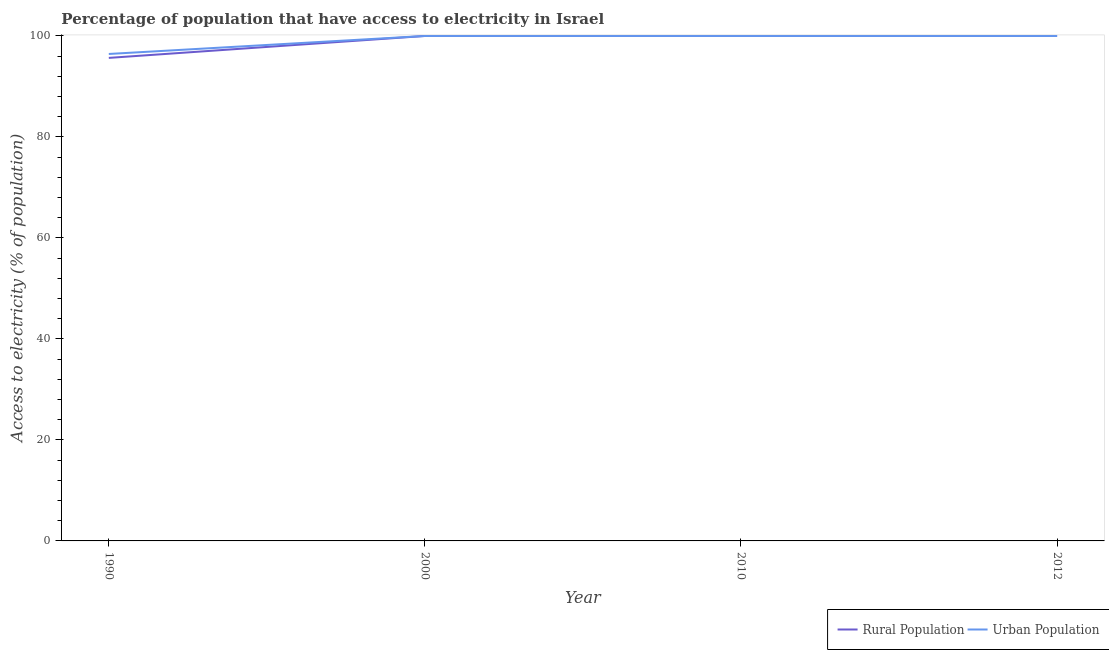How many different coloured lines are there?
Provide a succinct answer. 2. Does the line corresponding to percentage of urban population having access to electricity intersect with the line corresponding to percentage of rural population having access to electricity?
Offer a very short reply. Yes. Is the number of lines equal to the number of legend labels?
Provide a succinct answer. Yes. What is the percentage of urban population having access to electricity in 1990?
Your answer should be compact. 96.44. Across all years, what is the maximum percentage of rural population having access to electricity?
Provide a short and direct response. 100. Across all years, what is the minimum percentage of urban population having access to electricity?
Provide a short and direct response. 96.44. In which year was the percentage of rural population having access to electricity maximum?
Provide a succinct answer. 2000. What is the total percentage of urban population having access to electricity in the graph?
Your response must be concise. 396.44. What is the average percentage of urban population having access to electricity per year?
Give a very brief answer. 99.11. In the year 2000, what is the difference between the percentage of rural population having access to electricity and percentage of urban population having access to electricity?
Offer a very short reply. 0. In how many years, is the percentage of urban population having access to electricity greater than 96 %?
Give a very brief answer. 4. What is the difference between the highest and the lowest percentage of urban population having access to electricity?
Keep it short and to the point. 3.56. In how many years, is the percentage of rural population having access to electricity greater than the average percentage of rural population having access to electricity taken over all years?
Provide a succinct answer. 3. Does the percentage of urban population having access to electricity monotonically increase over the years?
Ensure brevity in your answer.  No. Is the percentage of urban population having access to electricity strictly greater than the percentage of rural population having access to electricity over the years?
Ensure brevity in your answer.  No. How many years are there in the graph?
Provide a succinct answer. 4. How many legend labels are there?
Offer a very short reply. 2. How are the legend labels stacked?
Your response must be concise. Horizontal. What is the title of the graph?
Keep it short and to the point. Percentage of population that have access to electricity in Israel. Does "Public credit registry" appear as one of the legend labels in the graph?
Your answer should be very brief. No. What is the label or title of the X-axis?
Keep it short and to the point. Year. What is the label or title of the Y-axis?
Your answer should be very brief. Access to electricity (% of population). What is the Access to electricity (% of population) in Rural Population in 1990?
Provide a short and direct response. 95.66. What is the Access to electricity (% of population) in Urban Population in 1990?
Offer a terse response. 96.44. What is the Access to electricity (% of population) in Rural Population in 2000?
Your response must be concise. 100. What is the Access to electricity (% of population) in Rural Population in 2010?
Your answer should be compact. 100. What is the Access to electricity (% of population) of Urban Population in 2010?
Give a very brief answer. 100. What is the Access to electricity (% of population) of Urban Population in 2012?
Keep it short and to the point. 100. Across all years, what is the maximum Access to electricity (% of population) of Urban Population?
Ensure brevity in your answer.  100. Across all years, what is the minimum Access to electricity (% of population) of Rural Population?
Offer a terse response. 95.66. Across all years, what is the minimum Access to electricity (% of population) of Urban Population?
Offer a terse response. 96.44. What is the total Access to electricity (% of population) of Rural Population in the graph?
Make the answer very short. 395.66. What is the total Access to electricity (% of population) of Urban Population in the graph?
Keep it short and to the point. 396.44. What is the difference between the Access to electricity (% of population) in Rural Population in 1990 and that in 2000?
Keep it short and to the point. -4.34. What is the difference between the Access to electricity (% of population) of Urban Population in 1990 and that in 2000?
Ensure brevity in your answer.  -3.56. What is the difference between the Access to electricity (% of population) of Rural Population in 1990 and that in 2010?
Offer a very short reply. -4.34. What is the difference between the Access to electricity (% of population) in Urban Population in 1990 and that in 2010?
Give a very brief answer. -3.56. What is the difference between the Access to electricity (% of population) in Rural Population in 1990 and that in 2012?
Ensure brevity in your answer.  -4.34. What is the difference between the Access to electricity (% of population) in Urban Population in 1990 and that in 2012?
Make the answer very short. -3.56. What is the difference between the Access to electricity (% of population) in Rural Population in 2000 and that in 2010?
Your answer should be very brief. 0. What is the difference between the Access to electricity (% of population) of Urban Population in 2000 and that in 2010?
Your answer should be compact. 0. What is the difference between the Access to electricity (% of population) in Urban Population in 2000 and that in 2012?
Keep it short and to the point. 0. What is the difference between the Access to electricity (% of population) in Rural Population in 2010 and that in 2012?
Your answer should be compact. 0. What is the difference between the Access to electricity (% of population) in Rural Population in 1990 and the Access to electricity (% of population) in Urban Population in 2000?
Provide a succinct answer. -4.34. What is the difference between the Access to electricity (% of population) in Rural Population in 1990 and the Access to electricity (% of population) in Urban Population in 2010?
Give a very brief answer. -4.34. What is the difference between the Access to electricity (% of population) in Rural Population in 1990 and the Access to electricity (% of population) in Urban Population in 2012?
Ensure brevity in your answer.  -4.34. What is the difference between the Access to electricity (% of population) in Rural Population in 2000 and the Access to electricity (% of population) in Urban Population in 2010?
Your response must be concise. 0. What is the difference between the Access to electricity (% of population) in Rural Population in 2000 and the Access to electricity (% of population) in Urban Population in 2012?
Provide a short and direct response. 0. What is the difference between the Access to electricity (% of population) of Rural Population in 2010 and the Access to electricity (% of population) of Urban Population in 2012?
Your answer should be compact. 0. What is the average Access to electricity (% of population) of Rural Population per year?
Your answer should be compact. 98.92. What is the average Access to electricity (% of population) in Urban Population per year?
Give a very brief answer. 99.11. In the year 1990, what is the difference between the Access to electricity (% of population) of Rural Population and Access to electricity (% of population) of Urban Population?
Provide a succinct answer. -0.78. In the year 2010, what is the difference between the Access to electricity (% of population) of Rural Population and Access to electricity (% of population) of Urban Population?
Provide a short and direct response. 0. In the year 2012, what is the difference between the Access to electricity (% of population) of Rural Population and Access to electricity (% of population) of Urban Population?
Keep it short and to the point. 0. What is the ratio of the Access to electricity (% of population) of Rural Population in 1990 to that in 2000?
Your answer should be compact. 0.96. What is the ratio of the Access to electricity (% of population) in Urban Population in 1990 to that in 2000?
Your answer should be compact. 0.96. What is the ratio of the Access to electricity (% of population) of Rural Population in 1990 to that in 2010?
Provide a short and direct response. 0.96. What is the ratio of the Access to electricity (% of population) in Urban Population in 1990 to that in 2010?
Your response must be concise. 0.96. What is the ratio of the Access to electricity (% of population) of Rural Population in 1990 to that in 2012?
Your answer should be compact. 0.96. What is the ratio of the Access to electricity (% of population) of Urban Population in 1990 to that in 2012?
Offer a very short reply. 0.96. What is the ratio of the Access to electricity (% of population) in Rural Population in 2000 to that in 2010?
Your answer should be compact. 1. What is the ratio of the Access to electricity (% of population) in Urban Population in 2000 to that in 2010?
Offer a very short reply. 1. What is the ratio of the Access to electricity (% of population) in Urban Population in 2000 to that in 2012?
Make the answer very short. 1. What is the difference between the highest and the second highest Access to electricity (% of population) of Urban Population?
Your response must be concise. 0. What is the difference between the highest and the lowest Access to electricity (% of population) of Rural Population?
Give a very brief answer. 4.34. What is the difference between the highest and the lowest Access to electricity (% of population) of Urban Population?
Your answer should be very brief. 3.56. 